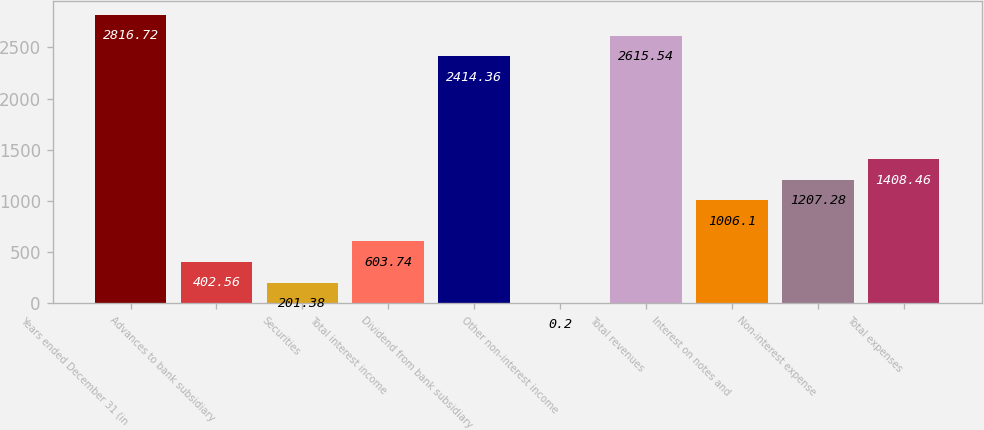Convert chart to OTSL. <chart><loc_0><loc_0><loc_500><loc_500><bar_chart><fcel>Years ended December 31 (in<fcel>Advances to bank subsidiary<fcel>Securities<fcel>Total interest income<fcel>Dividend from bank subsidiary<fcel>Other non-interest income<fcel>Total revenues<fcel>Interest on notes and<fcel>Non-interest expense<fcel>Total expenses<nl><fcel>2816.72<fcel>402.56<fcel>201.38<fcel>603.74<fcel>2414.36<fcel>0.2<fcel>2615.54<fcel>1006.1<fcel>1207.28<fcel>1408.46<nl></chart> 